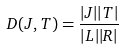Convert formula to latex. <formula><loc_0><loc_0><loc_500><loc_500>D ( J , T ) = \frac { | J | | T | } { | L | | R | }</formula> 